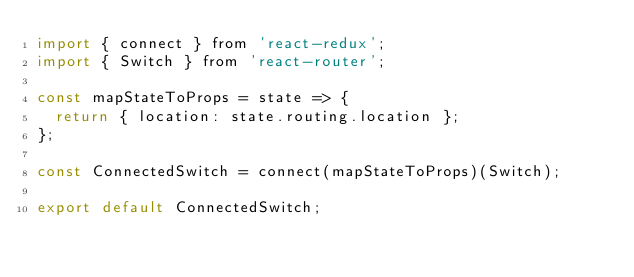<code> <loc_0><loc_0><loc_500><loc_500><_JavaScript_>import { connect } from 'react-redux';
import { Switch } from 'react-router';

const mapStateToProps = state => {
  return { location: state.routing.location };
};

const ConnectedSwitch = connect(mapStateToProps)(Switch);

export default ConnectedSwitch;
</code> 